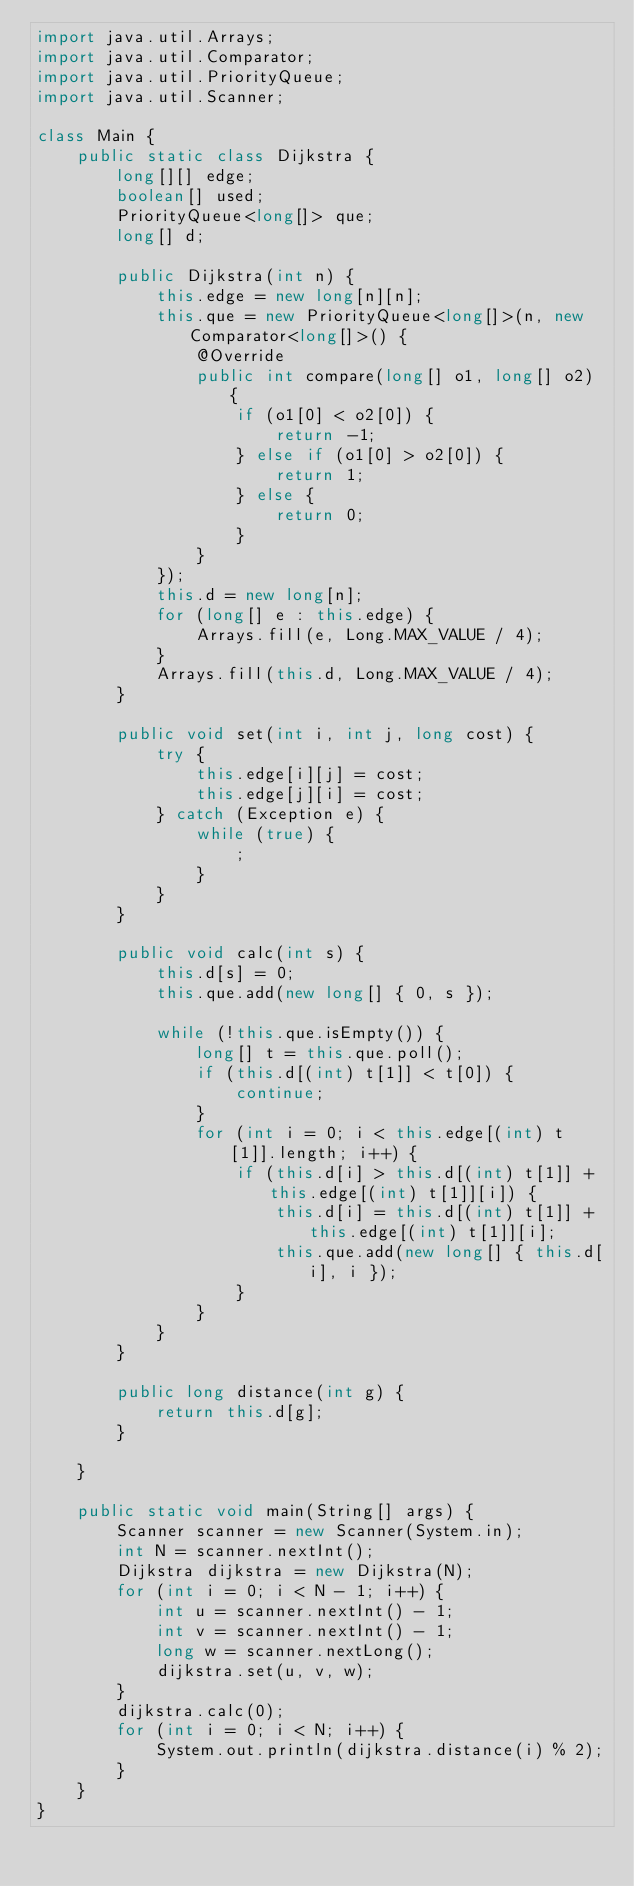<code> <loc_0><loc_0><loc_500><loc_500><_Java_>import java.util.Arrays;
import java.util.Comparator;
import java.util.PriorityQueue;
import java.util.Scanner;

class Main {
    public static class Dijkstra {
        long[][] edge;
        boolean[] used;
        PriorityQueue<long[]> que;
        long[] d;

        public Dijkstra(int n) {
            this.edge = new long[n][n];
            this.que = new PriorityQueue<long[]>(n, new Comparator<long[]>() {
                @Override
                public int compare(long[] o1, long[] o2) {
                    if (o1[0] < o2[0]) {
                        return -1;
                    } else if (o1[0] > o2[0]) {
                        return 1;
                    } else {
                        return 0;
                    }
                }
            });
            this.d = new long[n];
            for (long[] e : this.edge) {
                Arrays.fill(e, Long.MAX_VALUE / 4);
            }
            Arrays.fill(this.d, Long.MAX_VALUE / 4);
        }

        public void set(int i, int j, long cost) {
            try {
                this.edge[i][j] = cost;
                this.edge[j][i] = cost;
            } catch (Exception e) {
                while (true) {
                    ;
                }
            }
        }

        public void calc(int s) {
            this.d[s] = 0;
            this.que.add(new long[] { 0, s });

            while (!this.que.isEmpty()) {
                long[] t = this.que.poll();
                if (this.d[(int) t[1]] < t[0]) {
                    continue;
                }
                for (int i = 0; i < this.edge[(int) t[1]].length; i++) {
                    if (this.d[i] > this.d[(int) t[1]] + this.edge[(int) t[1]][i]) {
                        this.d[i] = this.d[(int) t[1]] + this.edge[(int) t[1]][i];
                        this.que.add(new long[] { this.d[i], i });
                    }
                }
            }
        }

        public long distance(int g) {
            return this.d[g];
        }

    }

    public static void main(String[] args) {
        Scanner scanner = new Scanner(System.in);
        int N = scanner.nextInt();
        Dijkstra dijkstra = new Dijkstra(N);
        for (int i = 0; i < N - 1; i++) {
            int u = scanner.nextInt() - 1;
            int v = scanner.nextInt() - 1;
            long w = scanner.nextLong();
            dijkstra.set(u, v, w);
        }
        dijkstra.calc(0);
        for (int i = 0; i < N; i++) {
            System.out.println(dijkstra.distance(i) % 2);
        }
    }
}
</code> 